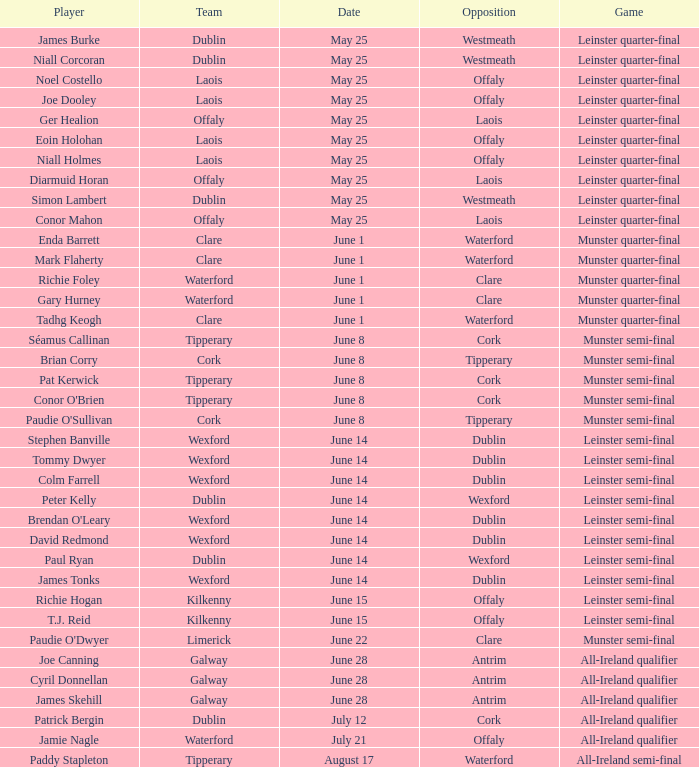In which contest did eoin holohan take part? Leinster quarter-final. 